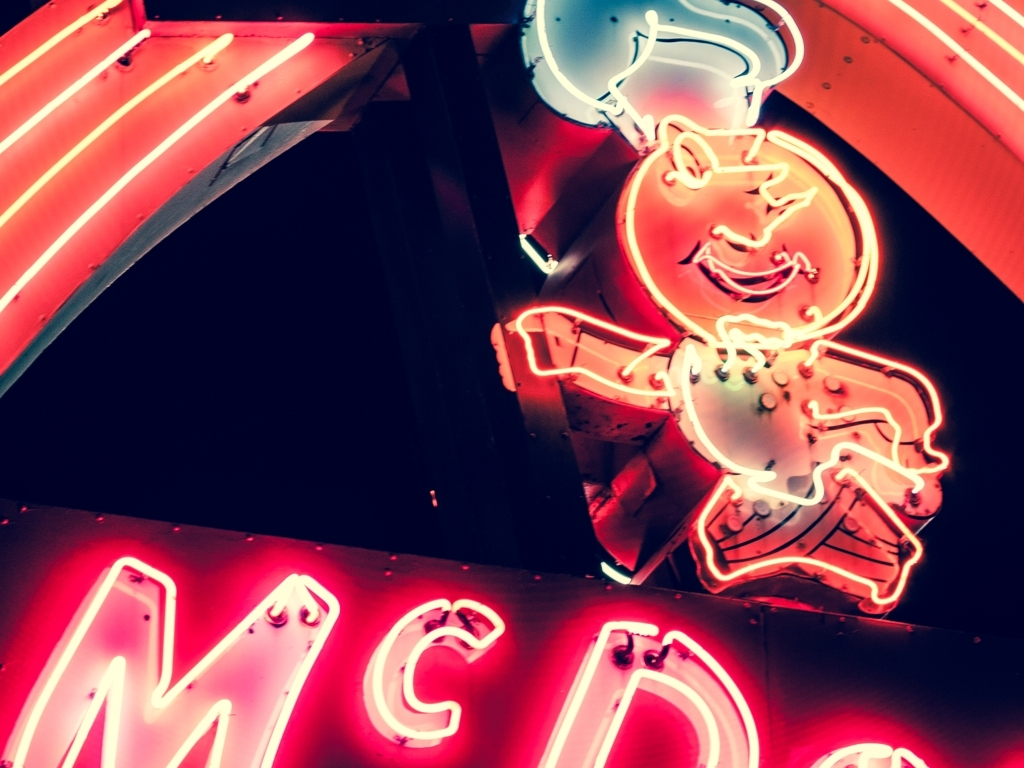What era does the image's aesthetic seem to evoke? The image's aesthetic evokes the mid-20th century, reminiscent of classic Americana with its bold neon signage and iconic typography. It reflects a time when such signs were commonly used to attract customers to diners, drive-ins, and roadside stands. 